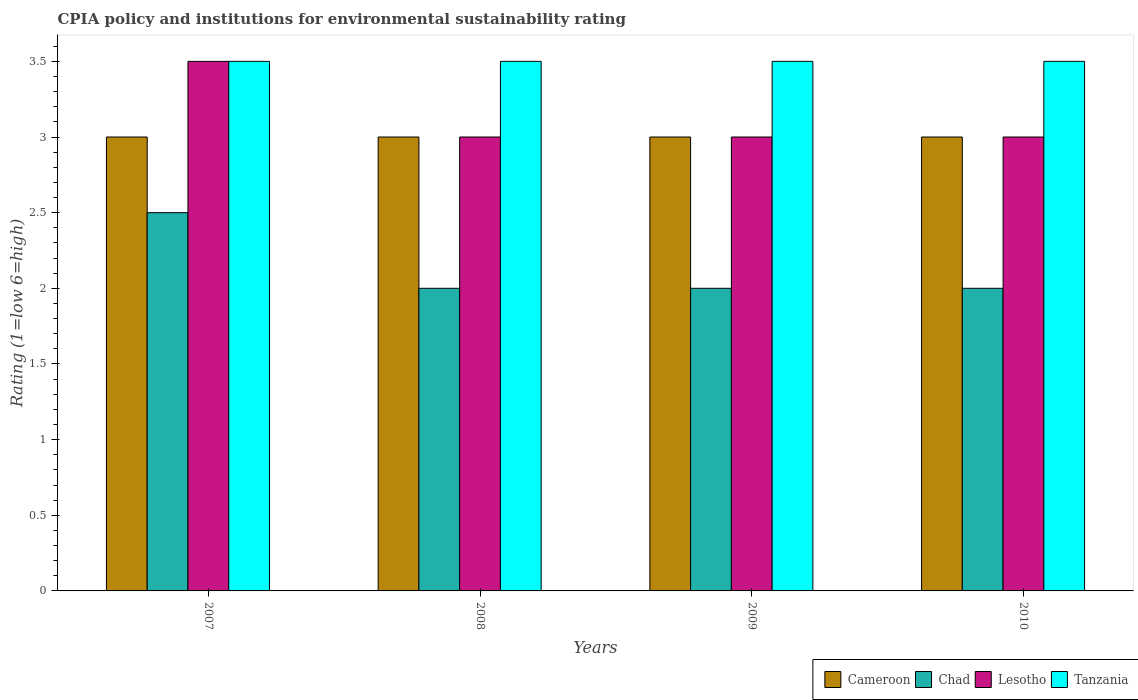How many groups of bars are there?
Offer a very short reply. 4. Are the number of bars on each tick of the X-axis equal?
Provide a short and direct response. Yes. How many bars are there on the 4th tick from the left?
Give a very brief answer. 4. How many bars are there on the 3rd tick from the right?
Ensure brevity in your answer.  4. What is the label of the 4th group of bars from the left?
Your answer should be compact. 2010. In how many cases, is the number of bars for a given year not equal to the number of legend labels?
Offer a very short reply. 0. What is the CPIA rating in Cameroon in 2009?
Keep it short and to the point. 3. Across all years, what is the minimum CPIA rating in Tanzania?
Provide a short and direct response. 3.5. In which year was the CPIA rating in Chad minimum?
Offer a terse response. 2008. What is the total CPIA rating in Cameroon in the graph?
Ensure brevity in your answer.  12. What is the difference between the CPIA rating in Tanzania in 2007 and that in 2010?
Make the answer very short. 0. What is the average CPIA rating in Chad per year?
Keep it short and to the point. 2.12. In the year 2010, what is the difference between the CPIA rating in Cameroon and CPIA rating in Tanzania?
Offer a very short reply. -0.5. What is the ratio of the CPIA rating in Chad in 2008 to that in 2010?
Your response must be concise. 1. What is the difference between the highest and the second highest CPIA rating in Lesotho?
Offer a terse response. 0.5. In how many years, is the CPIA rating in Tanzania greater than the average CPIA rating in Tanzania taken over all years?
Your answer should be compact. 0. Is it the case that in every year, the sum of the CPIA rating in Chad and CPIA rating in Tanzania is greater than the sum of CPIA rating in Cameroon and CPIA rating in Lesotho?
Your answer should be compact. No. What does the 1st bar from the left in 2009 represents?
Your answer should be compact. Cameroon. What does the 1st bar from the right in 2010 represents?
Ensure brevity in your answer.  Tanzania. How many bars are there?
Provide a succinct answer. 16. Are all the bars in the graph horizontal?
Your response must be concise. No. What is the difference between two consecutive major ticks on the Y-axis?
Ensure brevity in your answer.  0.5. Are the values on the major ticks of Y-axis written in scientific E-notation?
Your answer should be compact. No. Does the graph contain grids?
Your answer should be very brief. No. Where does the legend appear in the graph?
Make the answer very short. Bottom right. What is the title of the graph?
Ensure brevity in your answer.  CPIA policy and institutions for environmental sustainability rating. What is the label or title of the X-axis?
Offer a terse response. Years. What is the label or title of the Y-axis?
Provide a short and direct response. Rating (1=low 6=high). What is the Rating (1=low 6=high) in Lesotho in 2007?
Give a very brief answer. 3.5. What is the Rating (1=low 6=high) in Lesotho in 2008?
Your response must be concise. 3. What is the Rating (1=low 6=high) in Tanzania in 2009?
Ensure brevity in your answer.  3.5. What is the Rating (1=low 6=high) of Chad in 2010?
Your answer should be very brief. 2. What is the Rating (1=low 6=high) in Lesotho in 2010?
Offer a terse response. 3. What is the Rating (1=low 6=high) in Tanzania in 2010?
Provide a succinct answer. 3.5. Across all years, what is the maximum Rating (1=low 6=high) of Cameroon?
Your response must be concise. 3. Across all years, what is the maximum Rating (1=low 6=high) in Chad?
Provide a short and direct response. 2.5. Across all years, what is the maximum Rating (1=low 6=high) of Lesotho?
Ensure brevity in your answer.  3.5. Across all years, what is the maximum Rating (1=low 6=high) of Tanzania?
Your answer should be very brief. 3.5. Across all years, what is the minimum Rating (1=low 6=high) in Chad?
Offer a very short reply. 2. What is the total Rating (1=low 6=high) in Cameroon in the graph?
Your response must be concise. 12. What is the total Rating (1=low 6=high) of Chad in the graph?
Provide a succinct answer. 8.5. What is the difference between the Rating (1=low 6=high) of Chad in 2007 and that in 2008?
Offer a terse response. 0.5. What is the difference between the Rating (1=low 6=high) of Tanzania in 2007 and that in 2008?
Your answer should be very brief. 0. What is the difference between the Rating (1=low 6=high) in Chad in 2007 and that in 2009?
Provide a short and direct response. 0.5. What is the difference between the Rating (1=low 6=high) of Lesotho in 2007 and that in 2009?
Your answer should be very brief. 0.5. What is the difference between the Rating (1=low 6=high) of Chad in 2007 and that in 2010?
Keep it short and to the point. 0.5. What is the difference between the Rating (1=low 6=high) of Lesotho in 2007 and that in 2010?
Offer a terse response. 0.5. What is the difference between the Rating (1=low 6=high) of Lesotho in 2008 and that in 2010?
Give a very brief answer. 0. What is the difference between the Rating (1=low 6=high) in Chad in 2009 and that in 2010?
Keep it short and to the point. 0. What is the difference between the Rating (1=low 6=high) in Tanzania in 2009 and that in 2010?
Offer a terse response. 0. What is the difference between the Rating (1=low 6=high) in Chad in 2007 and the Rating (1=low 6=high) in Lesotho in 2008?
Ensure brevity in your answer.  -0.5. What is the difference between the Rating (1=low 6=high) in Lesotho in 2007 and the Rating (1=low 6=high) in Tanzania in 2008?
Your answer should be very brief. 0. What is the difference between the Rating (1=low 6=high) in Cameroon in 2007 and the Rating (1=low 6=high) in Tanzania in 2009?
Offer a terse response. -0.5. What is the difference between the Rating (1=low 6=high) of Chad in 2007 and the Rating (1=low 6=high) of Lesotho in 2009?
Provide a succinct answer. -0.5. What is the difference between the Rating (1=low 6=high) in Chad in 2007 and the Rating (1=low 6=high) in Lesotho in 2010?
Keep it short and to the point. -0.5. What is the difference between the Rating (1=low 6=high) of Lesotho in 2007 and the Rating (1=low 6=high) of Tanzania in 2010?
Offer a very short reply. 0. What is the difference between the Rating (1=low 6=high) in Cameroon in 2008 and the Rating (1=low 6=high) in Tanzania in 2009?
Make the answer very short. -0.5. What is the difference between the Rating (1=low 6=high) of Chad in 2008 and the Rating (1=low 6=high) of Lesotho in 2009?
Offer a very short reply. -1. What is the difference between the Rating (1=low 6=high) in Cameroon in 2008 and the Rating (1=low 6=high) in Lesotho in 2010?
Make the answer very short. 0. What is the difference between the Rating (1=low 6=high) of Cameroon in 2008 and the Rating (1=low 6=high) of Tanzania in 2010?
Your answer should be compact. -0.5. What is the difference between the Rating (1=low 6=high) in Chad in 2008 and the Rating (1=low 6=high) in Tanzania in 2010?
Your answer should be compact. -1.5. What is the difference between the Rating (1=low 6=high) of Cameroon in 2009 and the Rating (1=low 6=high) of Tanzania in 2010?
Ensure brevity in your answer.  -0.5. What is the average Rating (1=low 6=high) of Cameroon per year?
Provide a short and direct response. 3. What is the average Rating (1=low 6=high) of Chad per year?
Your response must be concise. 2.12. What is the average Rating (1=low 6=high) in Lesotho per year?
Give a very brief answer. 3.12. In the year 2007, what is the difference between the Rating (1=low 6=high) in Cameroon and Rating (1=low 6=high) in Lesotho?
Offer a terse response. -0.5. In the year 2007, what is the difference between the Rating (1=low 6=high) in Chad and Rating (1=low 6=high) in Tanzania?
Ensure brevity in your answer.  -1. In the year 2007, what is the difference between the Rating (1=low 6=high) of Lesotho and Rating (1=low 6=high) of Tanzania?
Your answer should be very brief. 0. In the year 2008, what is the difference between the Rating (1=low 6=high) of Cameroon and Rating (1=low 6=high) of Chad?
Offer a terse response. 1. In the year 2008, what is the difference between the Rating (1=low 6=high) of Cameroon and Rating (1=low 6=high) of Lesotho?
Your answer should be very brief. 0. In the year 2008, what is the difference between the Rating (1=low 6=high) in Cameroon and Rating (1=low 6=high) in Tanzania?
Ensure brevity in your answer.  -0.5. In the year 2008, what is the difference between the Rating (1=low 6=high) in Chad and Rating (1=low 6=high) in Tanzania?
Provide a short and direct response. -1.5. In the year 2009, what is the difference between the Rating (1=low 6=high) in Cameroon and Rating (1=low 6=high) in Chad?
Keep it short and to the point. 1. In the year 2009, what is the difference between the Rating (1=low 6=high) of Cameroon and Rating (1=low 6=high) of Tanzania?
Your answer should be very brief. -0.5. In the year 2009, what is the difference between the Rating (1=low 6=high) in Chad and Rating (1=low 6=high) in Lesotho?
Give a very brief answer. -1. In the year 2010, what is the difference between the Rating (1=low 6=high) in Cameroon and Rating (1=low 6=high) in Chad?
Make the answer very short. 1. In the year 2010, what is the difference between the Rating (1=low 6=high) of Cameroon and Rating (1=low 6=high) of Lesotho?
Your answer should be very brief. 0. In the year 2010, what is the difference between the Rating (1=low 6=high) in Chad and Rating (1=low 6=high) in Lesotho?
Provide a succinct answer. -1. What is the ratio of the Rating (1=low 6=high) in Cameroon in 2007 to that in 2008?
Offer a very short reply. 1. What is the ratio of the Rating (1=low 6=high) in Chad in 2007 to that in 2008?
Provide a short and direct response. 1.25. What is the ratio of the Rating (1=low 6=high) of Chad in 2007 to that in 2009?
Your answer should be compact. 1.25. What is the ratio of the Rating (1=low 6=high) in Lesotho in 2007 to that in 2009?
Make the answer very short. 1.17. What is the ratio of the Rating (1=low 6=high) of Tanzania in 2007 to that in 2009?
Your answer should be compact. 1. What is the ratio of the Rating (1=low 6=high) in Cameroon in 2007 to that in 2010?
Make the answer very short. 1. What is the ratio of the Rating (1=low 6=high) of Chad in 2007 to that in 2010?
Make the answer very short. 1.25. What is the ratio of the Rating (1=low 6=high) of Tanzania in 2007 to that in 2010?
Offer a very short reply. 1. What is the ratio of the Rating (1=low 6=high) in Cameroon in 2008 to that in 2009?
Make the answer very short. 1. What is the ratio of the Rating (1=low 6=high) in Chad in 2008 to that in 2009?
Make the answer very short. 1. What is the ratio of the Rating (1=low 6=high) in Lesotho in 2008 to that in 2009?
Provide a short and direct response. 1. What is the ratio of the Rating (1=low 6=high) in Chad in 2008 to that in 2010?
Ensure brevity in your answer.  1. What is the ratio of the Rating (1=low 6=high) of Cameroon in 2009 to that in 2010?
Keep it short and to the point. 1. What is the ratio of the Rating (1=low 6=high) of Chad in 2009 to that in 2010?
Ensure brevity in your answer.  1. What is the ratio of the Rating (1=low 6=high) in Lesotho in 2009 to that in 2010?
Provide a succinct answer. 1. What is the ratio of the Rating (1=low 6=high) in Tanzania in 2009 to that in 2010?
Provide a succinct answer. 1. What is the difference between the highest and the second highest Rating (1=low 6=high) of Chad?
Provide a short and direct response. 0.5. What is the difference between the highest and the lowest Rating (1=low 6=high) of Lesotho?
Offer a very short reply. 0.5. What is the difference between the highest and the lowest Rating (1=low 6=high) of Tanzania?
Offer a terse response. 0. 